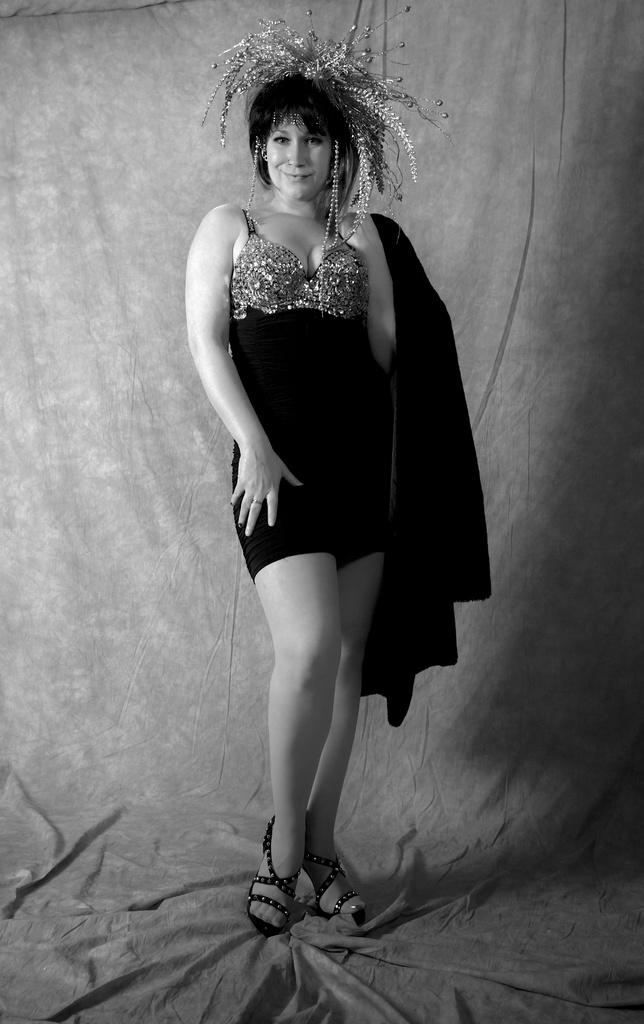What is the main subject of the image? There is a woman standing in the image. What color scheme is used in the image? The image is in black and white color. Can you tell me how many corn cobs are on the ground in the image? There is no corn present in the image; it only features a woman standing in a black and white setting. 